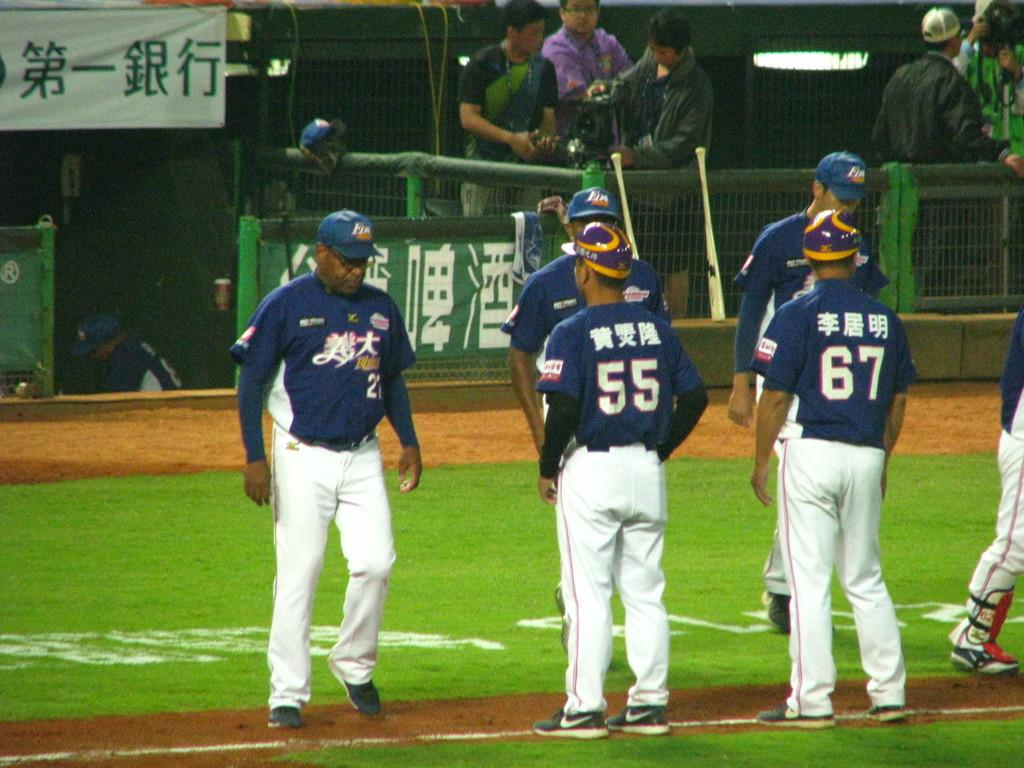<image>
Offer a succinct explanation of the picture presented. Baseball players on a field with Chinese symbol advertising and Chinese symbols on their shirts along with numbers 55,21 and 67. 